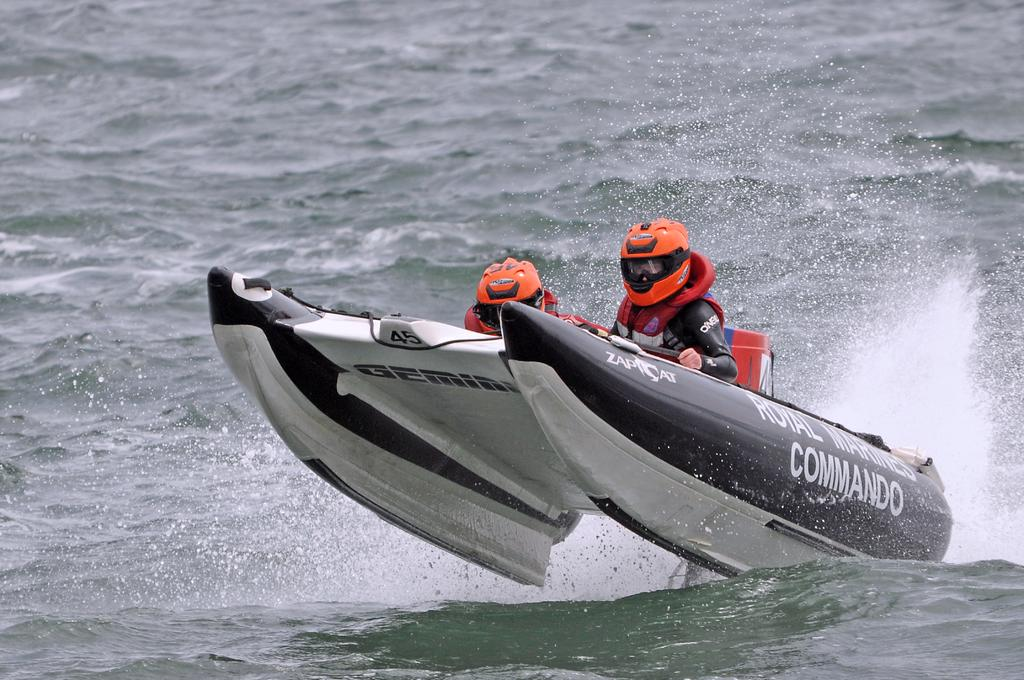<image>
Write a terse but informative summary of the picture. Two men in orange helmets are riding in a boat that says commando on the side. 